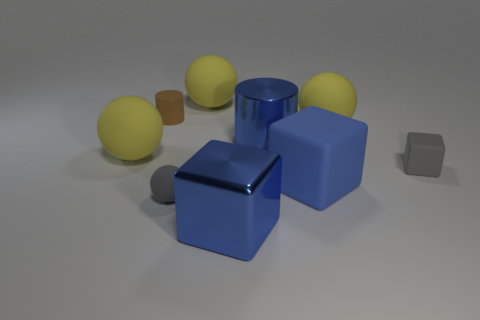The block to the left of the blue cylinder behind the big block on the left side of the metallic cylinder is made of what material?
Your answer should be very brief. Metal. There is a blue metal object that is the same size as the blue metal cylinder; what is its shape?
Provide a short and direct response. Cube. How many things are shiny cylinders or small objects on the left side of the gray block?
Your answer should be very brief. 3. Is the material of the big blue cube that is on the left side of the big blue metallic cylinder the same as the gray object left of the small cube?
Your answer should be very brief. No. The rubber object that is the same color as the big cylinder is what shape?
Your response must be concise. Cube. What number of blue objects are either metallic things or matte objects?
Give a very brief answer. 3. How big is the brown cylinder?
Your answer should be very brief. Small. Is the number of blue rubber things behind the gray cube greater than the number of large gray metallic cylinders?
Ensure brevity in your answer.  No. What number of yellow things are to the left of the brown rubber cylinder?
Your answer should be very brief. 1. Are there any purple cylinders of the same size as the gray rubber block?
Offer a very short reply. No. 